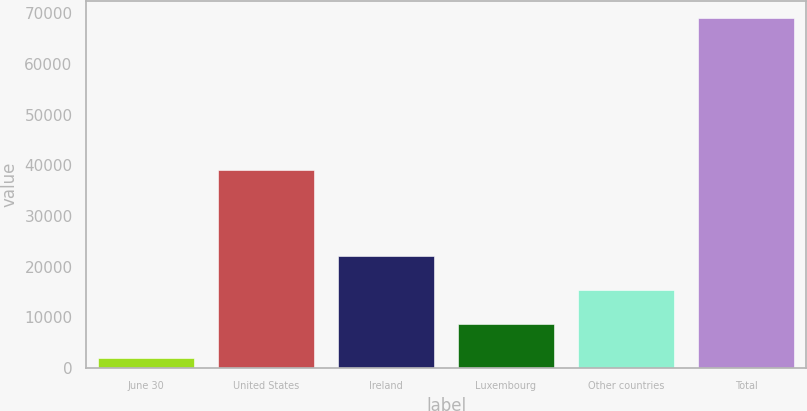Convert chart to OTSL. <chart><loc_0><loc_0><loc_500><loc_500><bar_chart><fcel>June 30<fcel>United States<fcel>Ireland<fcel>Luxembourg<fcel>Other countries<fcel>Total<nl><fcel>2017<fcel>39118<fcel>22100.5<fcel>8711.5<fcel>15406<fcel>68962<nl></chart> 